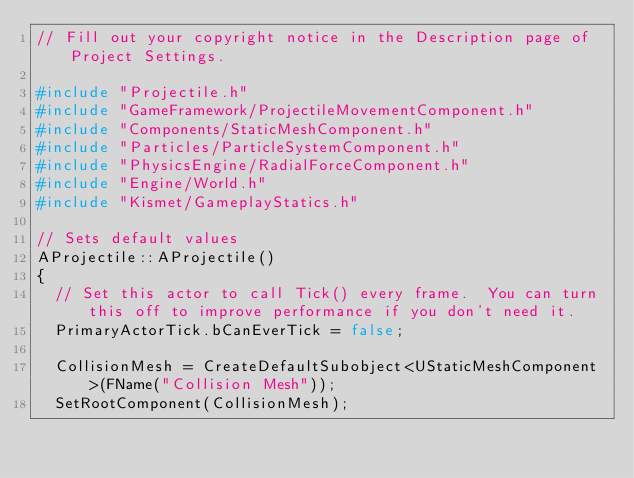<code> <loc_0><loc_0><loc_500><loc_500><_C++_>// Fill out your copyright notice in the Description page of Project Settings.

#include "Projectile.h"
#include "GameFramework/ProjectileMovementComponent.h"
#include "Components/StaticMeshComponent.h"
#include "Particles/ParticleSystemComponent.h"
#include "PhysicsEngine/RadialForceComponent.h"
#include "Engine/World.h"
#include "Kismet/GameplayStatics.h"

// Sets default values
AProjectile::AProjectile()
{
 	// Set this actor to call Tick() every frame.  You can turn this off to improve performance if you don't need it.
	PrimaryActorTick.bCanEverTick = false;

	CollisionMesh = CreateDefaultSubobject<UStaticMeshComponent>(FName("Collision Mesh"));
	SetRootComponent(CollisionMesh);</code> 